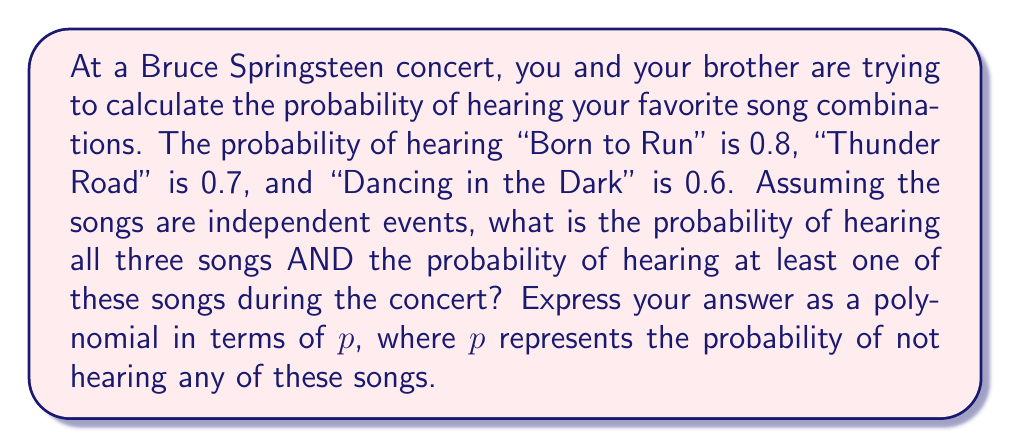Provide a solution to this math problem. Let's approach this step-by-step:

1) First, let's define our events:
   A: Hearing "Born to Run"
   B: Hearing "Thunder Road"
   C: Hearing "Dancing in the Dark"

2) The probability of hearing all three songs:
   $$P(A \cap B \cap C) = P(A) \cdot P(B) \cdot P(C) = 0.8 \cdot 0.7 \cdot 0.6 = 0.336$$

3) To find the probability of hearing at least one song, it's easier to calculate the probability of not hearing any of these songs and then subtract from 1:

   $$P(\text{at least one}) = 1 - P(\text{none})$$

4) The probability of not hearing a specific song:
   P(not A) = 1 - 0.8 = 0.2
   P(not B) = 1 - 0.7 = 0.3
   P(not C) = 1 - 0.6 = 0.4

5) The probability of not hearing any of these songs:
   $$P(\text{none}) = P(\text{not A}) \cdot P(\text{not B}) \cdot P(\text{not C}) = 0.2 \cdot 0.3 \cdot 0.4 = 0.024$$

6) Therefore, the probability of hearing at least one song:
   $$P(\text{at least one}) = 1 - 0.024 = 0.976$$

7) Now, let's express this in terms of $p$, where $p$ is the probability of not hearing any of these songs:

   Probability of hearing all three: $1 - p$
   Probability of hearing at least one: $1 - p$

8) The polynomial that represents both probabilities is:
   $$(1-p)^2$$

   When $p = 0.024$, this gives us both probabilities:
   $(1-0.024)^2 = 0.976^2 = 0.952576$

   The first term (0.976) is the probability of hearing at least one song, and multiplying it by itself gives us the probability of hearing all three songs (0.336, rounded to three decimal places).
Answer: $$(1-p)^2$$
where $p = 0.024$ 